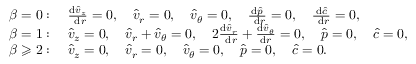Convert formula to latex. <formula><loc_0><loc_0><loc_500><loc_500>\begin{array} { r l } & { \beta = 0 \colon \quad \frac { d \hat { v } _ { z } } { d r } = 0 , \quad \hat { v } _ { r } = 0 , \quad \hat { v } _ { \theta } = 0 , \quad \frac { d \hat { p } } { d r } = 0 , \quad \frac { d \hat { c } } { d r } = 0 , } \\ & { \beta = 1 \colon \quad \hat { v } _ { z } = 0 , \quad \hat { v } _ { r } + \hat { v } _ { \theta } = 0 , \quad 2 \frac { d \hat { v } _ { r } } { d r } + \frac { d \hat { v } _ { \theta } } { d r } = 0 , \quad \hat { p } = 0 , \quad \hat { c } = 0 , } \\ & { \beta \geqslant 2 \colon \quad \hat { v } _ { z } = 0 , \quad \hat { v } _ { r } = 0 , \quad \hat { v } _ { \theta } = 0 , \quad \hat { p } = 0 , \quad \hat { c } = 0 . } \end{array}</formula> 